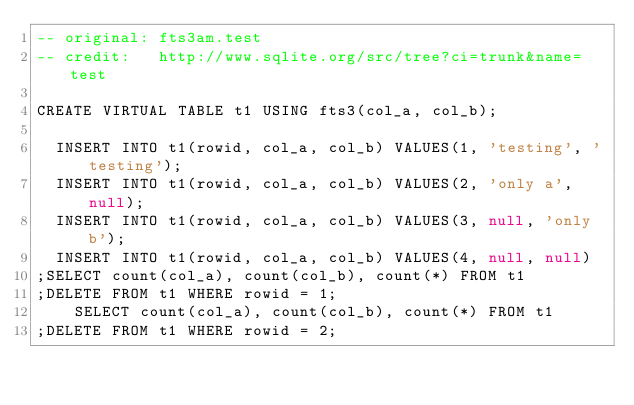Convert code to text. <code><loc_0><loc_0><loc_500><loc_500><_SQL_>-- original: fts3am.test
-- credit:   http://www.sqlite.org/src/tree?ci=trunk&name=test

CREATE VIRTUAL TABLE t1 USING fts3(col_a, col_b);

  INSERT INTO t1(rowid, col_a, col_b) VALUES(1, 'testing', 'testing');
  INSERT INTO t1(rowid, col_a, col_b) VALUES(2, 'only a', null);
  INSERT INTO t1(rowid, col_a, col_b) VALUES(3, null, 'only b');
  INSERT INTO t1(rowid, col_a, col_b) VALUES(4, null, null)
;SELECT count(col_a), count(col_b), count(*) FROM t1
;DELETE FROM t1 WHERE rowid = 1;
    SELECT count(col_a), count(col_b), count(*) FROM t1
;DELETE FROM t1 WHERE rowid = 2;</code> 